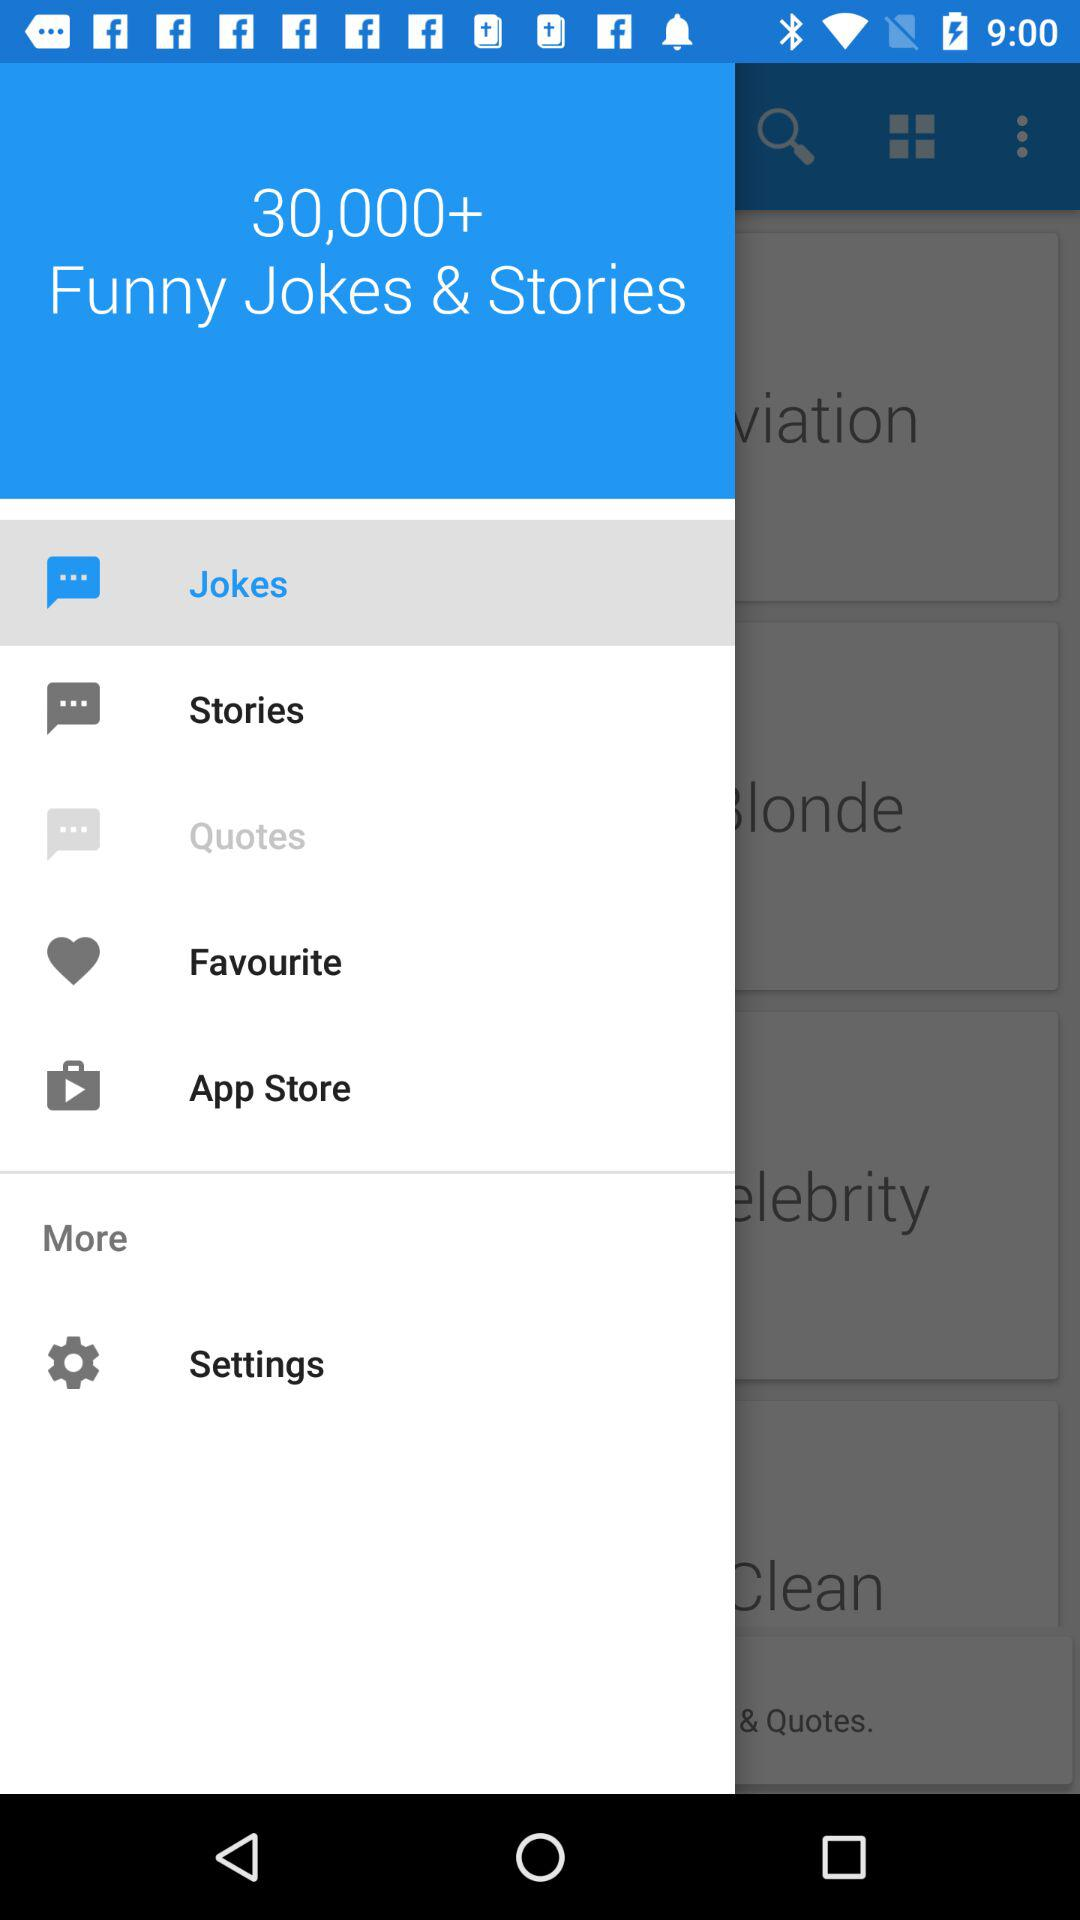What is the number of funny jokes & stories? The number of funny jokes & stories is 30,000+. 